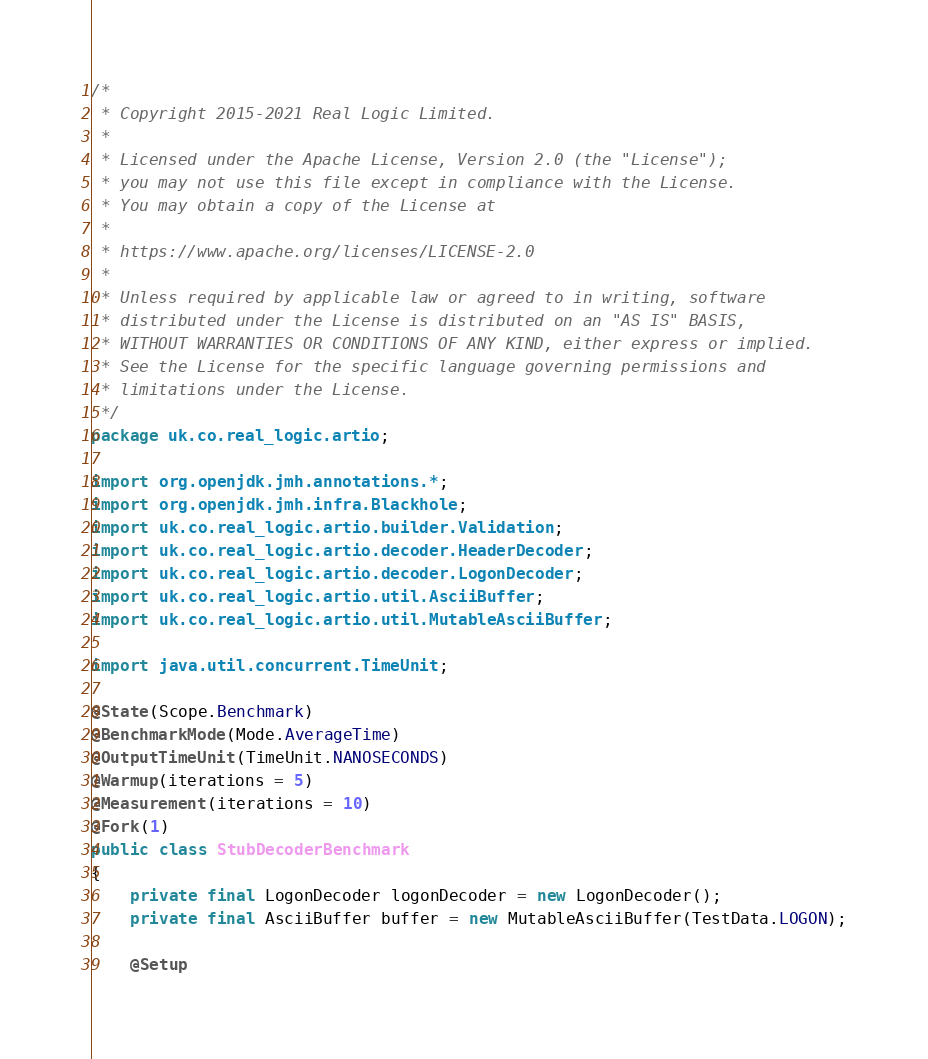Convert code to text. <code><loc_0><loc_0><loc_500><loc_500><_Java_>/*
 * Copyright 2015-2021 Real Logic Limited.
 *
 * Licensed under the Apache License, Version 2.0 (the "License");
 * you may not use this file except in compliance with the License.
 * You may obtain a copy of the License at
 *
 * https://www.apache.org/licenses/LICENSE-2.0
 *
 * Unless required by applicable law or agreed to in writing, software
 * distributed under the License is distributed on an "AS IS" BASIS,
 * WITHOUT WARRANTIES OR CONDITIONS OF ANY KIND, either express or implied.
 * See the License for the specific language governing permissions and
 * limitations under the License.
 */
package uk.co.real_logic.artio;

import org.openjdk.jmh.annotations.*;
import org.openjdk.jmh.infra.Blackhole;
import uk.co.real_logic.artio.builder.Validation;
import uk.co.real_logic.artio.decoder.HeaderDecoder;
import uk.co.real_logic.artio.decoder.LogonDecoder;
import uk.co.real_logic.artio.util.AsciiBuffer;
import uk.co.real_logic.artio.util.MutableAsciiBuffer;

import java.util.concurrent.TimeUnit;

@State(Scope.Benchmark)
@BenchmarkMode(Mode.AverageTime)
@OutputTimeUnit(TimeUnit.NANOSECONDS)
@Warmup(iterations = 5)
@Measurement(iterations = 10)
@Fork(1)
public class StubDecoderBenchmark
{
    private final LogonDecoder logonDecoder = new LogonDecoder();
    private final AsciiBuffer buffer = new MutableAsciiBuffer(TestData.LOGON);

    @Setup</code> 